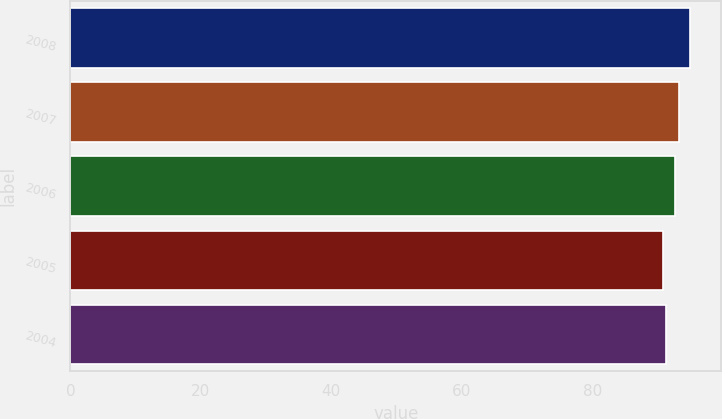Convert chart. <chart><loc_0><loc_0><loc_500><loc_500><bar_chart><fcel>2008<fcel>2007<fcel>2006<fcel>2005<fcel>2004<nl><fcel>95<fcel>93.3<fcel>92.6<fcel>90.9<fcel>91.31<nl></chart> 